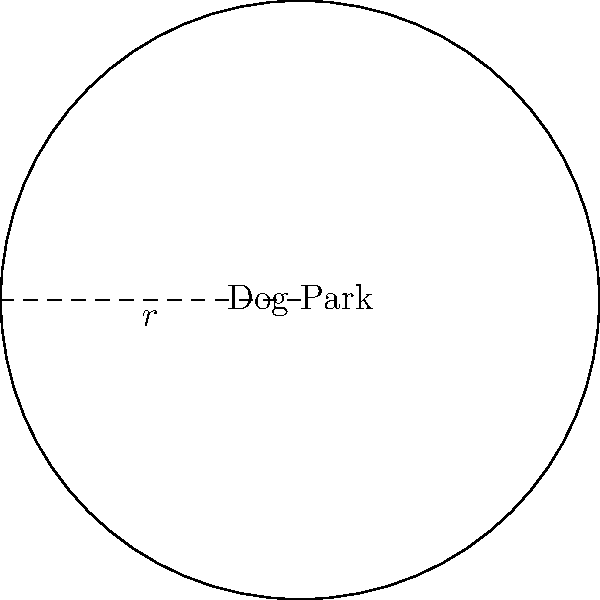As a busy single parent, you want to take your energetic puppy to a circular dog park. The park's radius is 30 meters. What is the total area of the dog park where your puppy can run and play? To find the area of a circular dog park, we need to use the formula for the area of a circle:

$$A = \pi r^2$$

Where:
$A$ = area of the circle
$\pi$ (pi) ≈ 3.14159
$r$ = radius of the circle

Given:
Radius ($r$) = 30 meters

Let's calculate the area:

$$\begin{align}
A &= \pi r^2 \\
&= \pi \cdot (30)^2 \\
&= \pi \cdot 900 \\
&≈ 3.14159 \cdot 900 \\
&≈ 2,827.43 \text{ square meters}
\end{align}$$

Rounding to the nearest whole number:
$$A ≈ 2,827 \text{ square meters}$$

This large area will give your energetic puppy plenty of space to run and play, helping to tire them out before you return home.
Answer: 2,827 square meters 